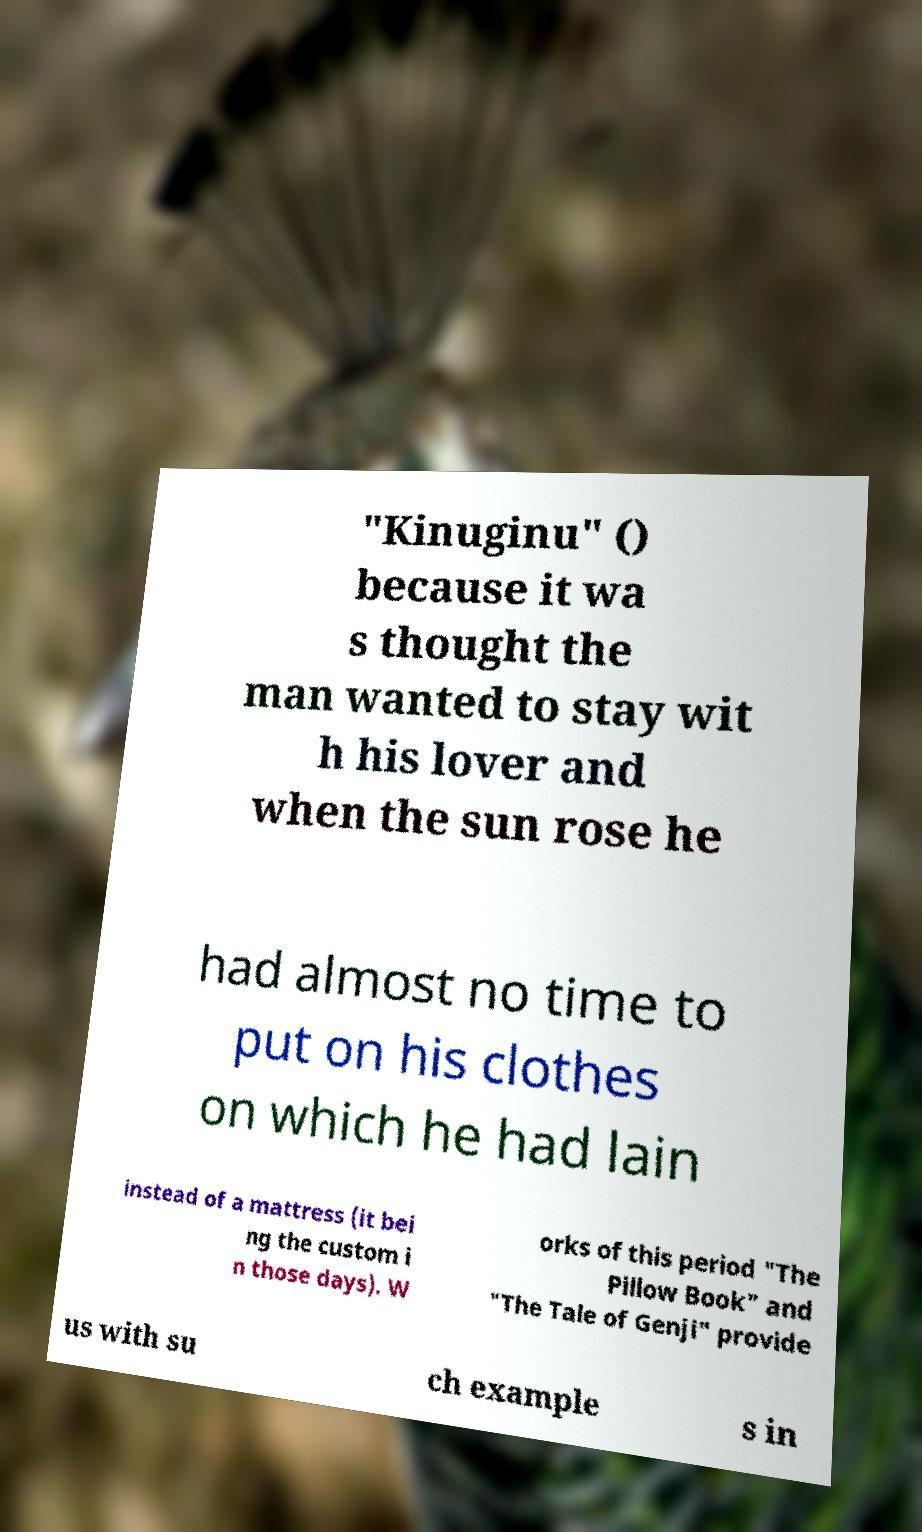Could you extract and type out the text from this image? "Kinuginu" () because it wa s thought the man wanted to stay wit h his lover and when the sun rose he had almost no time to put on his clothes on which he had lain instead of a mattress (it bei ng the custom i n those days). W orks of this period "The Pillow Book" and "The Tale of Genji" provide us with su ch example s in 